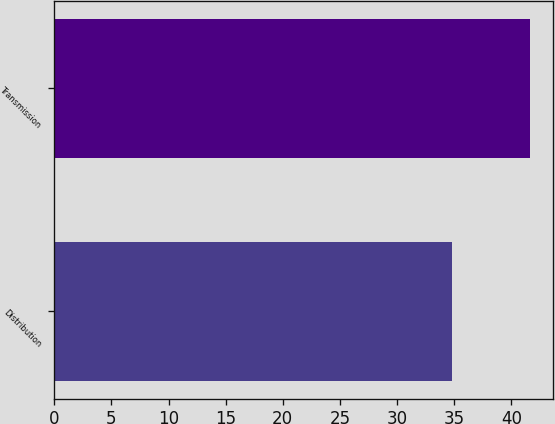<chart> <loc_0><loc_0><loc_500><loc_500><bar_chart><fcel>Distribution<fcel>Transmission<nl><fcel>34.8<fcel>41.6<nl></chart> 